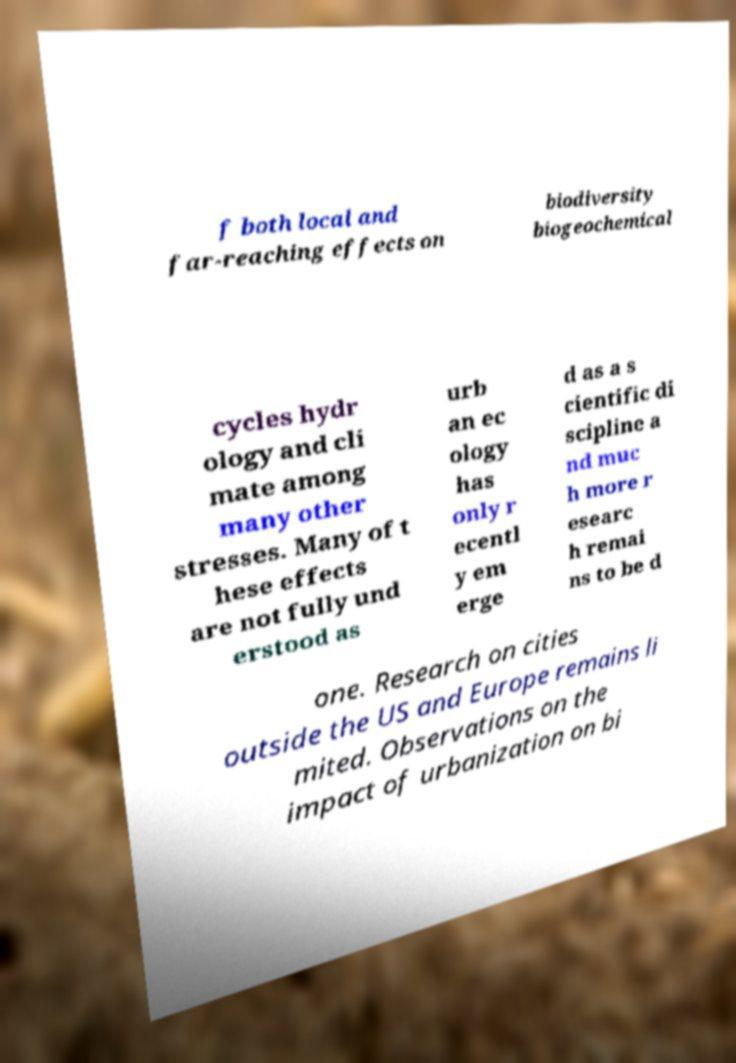Could you assist in decoding the text presented in this image and type it out clearly? f both local and far-reaching effects on biodiversity biogeochemical cycles hydr ology and cli mate among many other stresses. Many of t hese effects are not fully und erstood as urb an ec ology has only r ecentl y em erge d as a s cientific di scipline a nd muc h more r esearc h remai ns to be d one. Research on cities outside the US and Europe remains li mited. Observations on the impact of urbanization on bi 